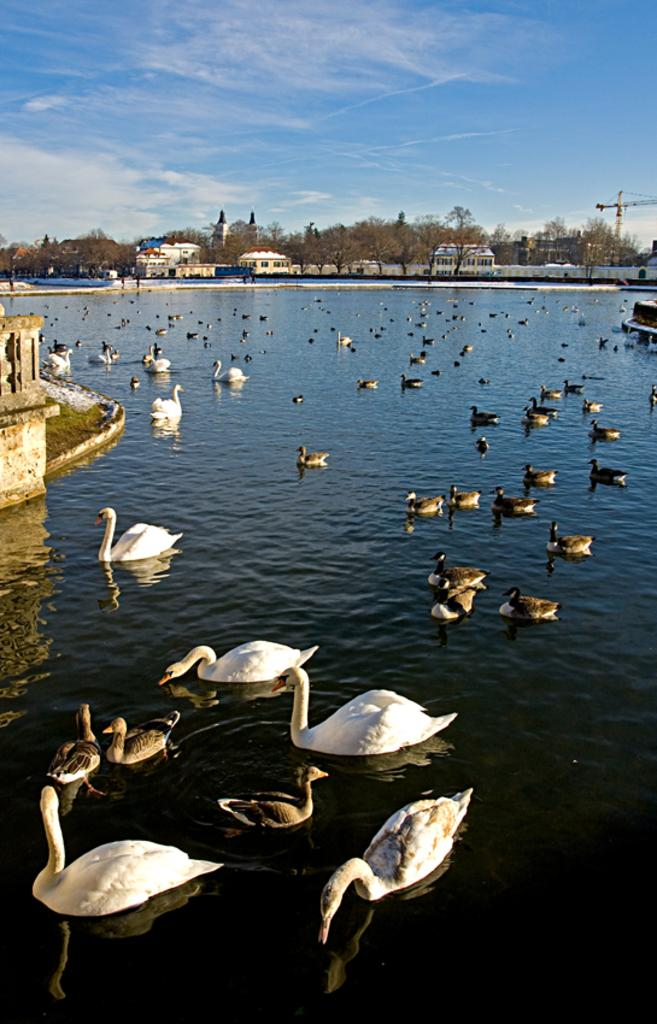What type of animals are in the water in the image? There are flocks of swans and other birds in the water in the image. What can be seen in the background of the image? There are houses, a fence, trees, and the sky visible in the background of the image. What is the weather like in the image? The image was taken during a sunny day. What type of quarter is visible on the shelf in the image? There is no shelf or quarter present in the image. What news can be heard coming from the houses in the image? There is no indication of any news or sounds coming from the houses in the image. 